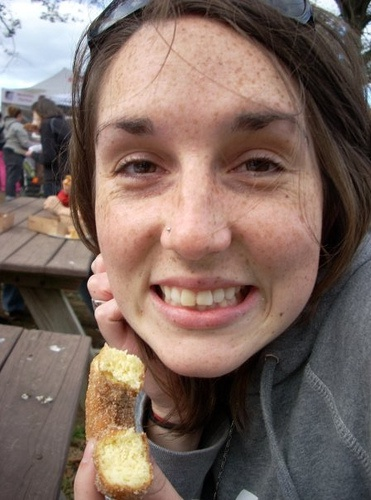Describe the objects in this image and their specific colors. I can see people in lavender, black, gray, and tan tones, dining table in lavender and gray tones, donut in lavender, khaki, tan, and gray tones, dining table in lavender, darkgray, and gray tones, and people in lavender, black, and gray tones in this image. 